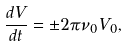<formula> <loc_0><loc_0><loc_500><loc_500>\frac { d V } { d t } = \pm 2 \pi \nu _ { 0 } V _ { 0 } ,</formula> 